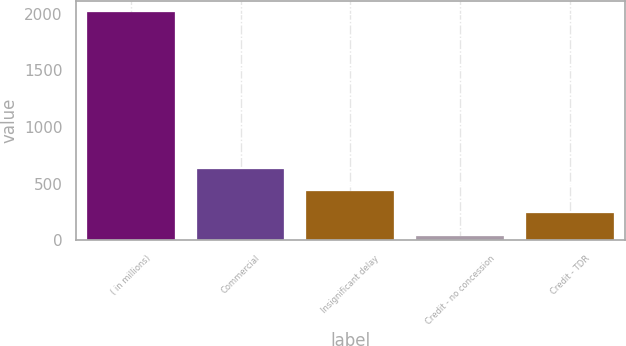<chart> <loc_0><loc_0><loc_500><loc_500><bar_chart><fcel>( in millions)<fcel>Commercial<fcel>Insignificant delay<fcel>Credit - no concession<fcel>Credit - TDR<nl><fcel>2012<fcel>632.3<fcel>435.2<fcel>41<fcel>238.1<nl></chart> 